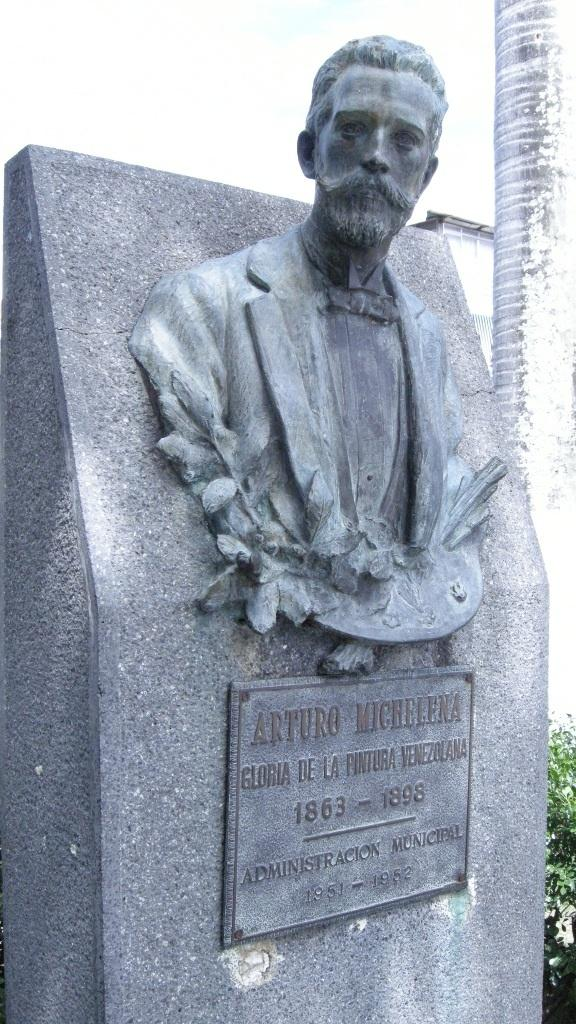What is the main subject of the image? There is a statue of a man in the image. Is there any text associated with the statue? Yes, there is a name plate with text in the image. What can be seen on the right side of the image? There appears to be a building on the right side of the image. Are there any plants in the image? Yes, there is a plant in the image. What type of setting does the image seem to depict? The image looks like a memorial. How many centimeters is the cannon in the image? There is no cannon present in the image. What type of music is the band playing in the image? There is no band present in the image. 